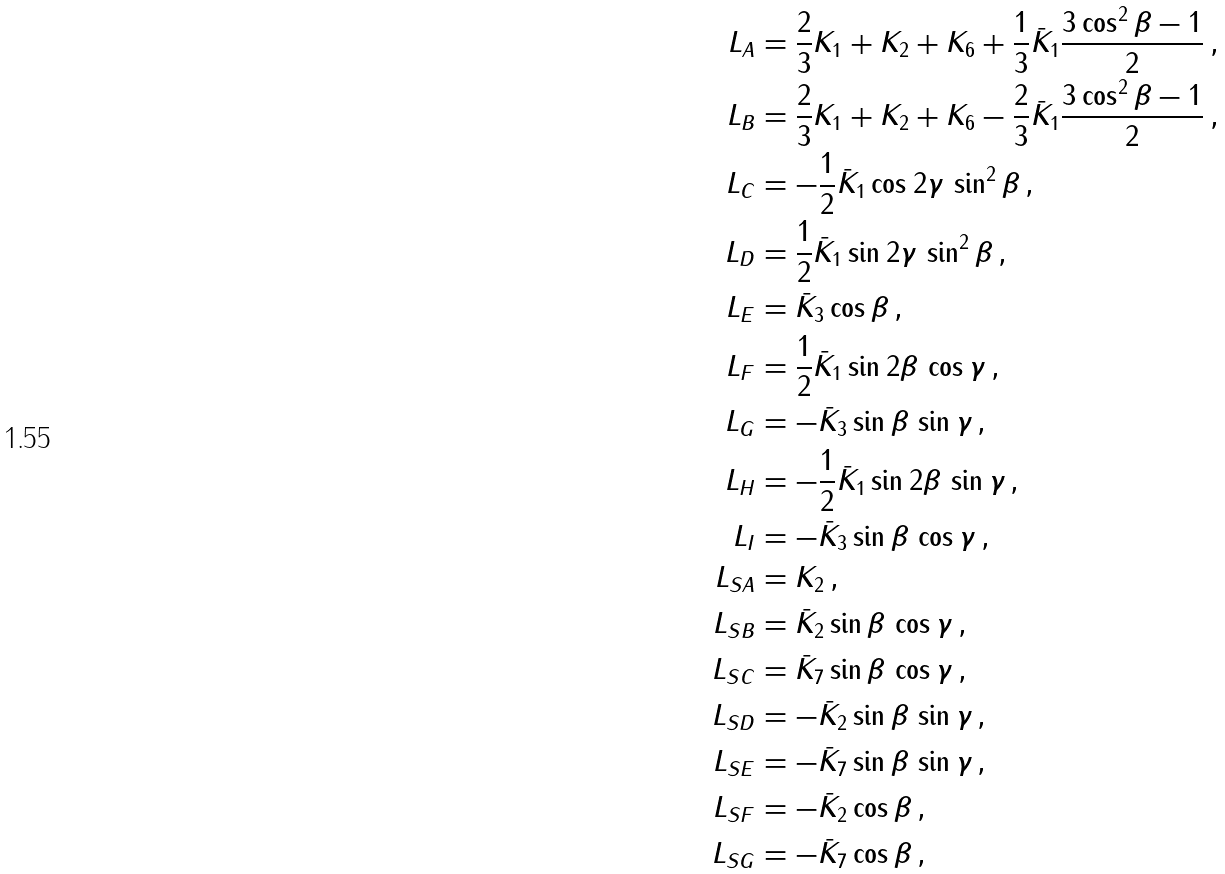Convert formula to latex. <formula><loc_0><loc_0><loc_500><loc_500>L _ { A } & = \frac { 2 } { 3 } K _ { 1 } + K _ { 2 } + K _ { 6 } + \frac { 1 } { 3 } \bar { K } _ { 1 } \frac { 3 \cos ^ { 2 } \beta - 1 } { 2 } \, , \\ L _ { B } & = \frac { 2 } { 3 } K _ { 1 } + K _ { 2 } + K _ { 6 } - \frac { 2 } { 3 } \bar { K } _ { 1 } \frac { 3 \cos ^ { 2 } \beta - 1 } { 2 } \, , \\ L _ { C } & = - \frac { 1 } { 2 } \bar { K } _ { 1 } \cos { 2 \gamma } \, \sin ^ { 2 } \beta \, , \\ L _ { D } & = \frac { 1 } { 2 } \bar { K } _ { 1 } \sin { 2 \gamma } \, \sin ^ { 2 } \beta \, , \\ L _ { E } & = \bar { K } _ { 3 } \cos \beta \, , \\ L _ { F } & = \frac { 1 } { 2 } \bar { K } _ { 1 } \sin { 2 \beta } \, \cos \gamma \, , \\ L _ { G } & = - \bar { K } _ { 3 } \sin \beta \, \sin \gamma \, , \\ L _ { H } & = - \frac { 1 } { 2 } \bar { K } _ { 1 } \sin { 2 \beta } \, \sin \gamma \, , \\ L _ { I } & = - \bar { K } _ { 3 } \sin \beta \, \cos \gamma \, , \\ L _ { S A } & = K _ { 2 } \, , \\ L _ { S B } & = \bar { K } _ { 2 } \sin \beta \, \cos \gamma \, , \\ L _ { S C } & = \bar { K } _ { 7 } \sin \beta \, \cos \gamma \, , \\ L _ { S D } & = - \bar { K } _ { 2 } \sin \beta \, \sin \gamma \, , \\ L _ { S E } & = - \bar { K } _ { 7 } \sin \beta \, \sin \gamma \, , \\ L _ { S F } & = - \bar { K } _ { 2 } \cos \beta \, , \\ L _ { S G } & = - \bar { K } _ { 7 } \cos \beta \, ,</formula> 